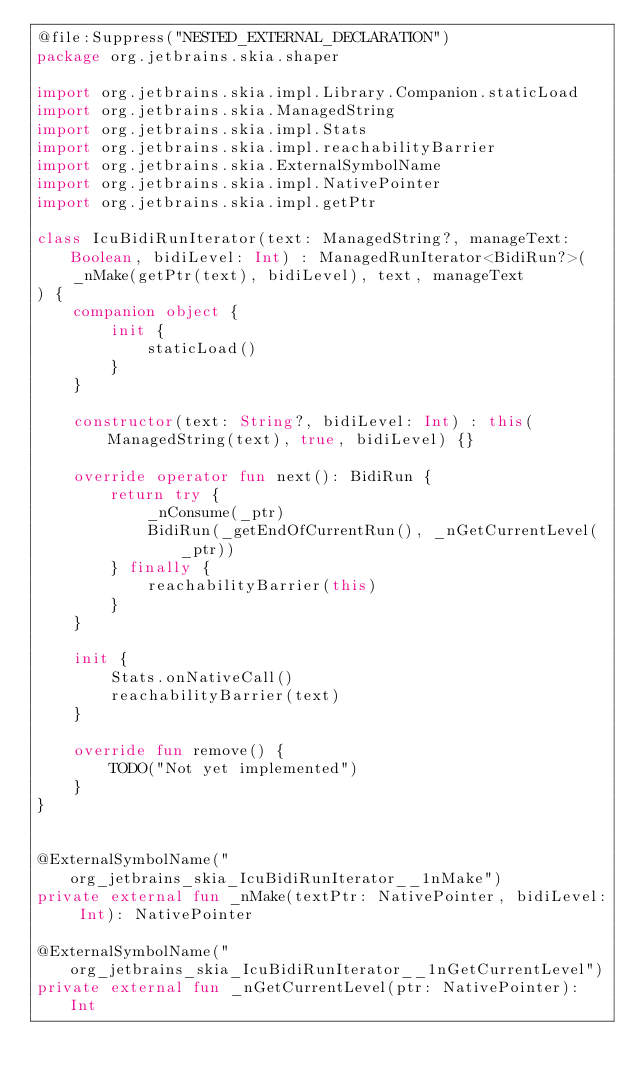Convert code to text. <code><loc_0><loc_0><loc_500><loc_500><_Kotlin_>@file:Suppress("NESTED_EXTERNAL_DECLARATION")
package org.jetbrains.skia.shaper

import org.jetbrains.skia.impl.Library.Companion.staticLoad
import org.jetbrains.skia.ManagedString
import org.jetbrains.skia.impl.Stats
import org.jetbrains.skia.impl.reachabilityBarrier
import org.jetbrains.skia.ExternalSymbolName
import org.jetbrains.skia.impl.NativePointer
import org.jetbrains.skia.impl.getPtr

class IcuBidiRunIterator(text: ManagedString?, manageText: Boolean, bidiLevel: Int) : ManagedRunIterator<BidiRun?>(
    _nMake(getPtr(text), bidiLevel), text, manageText
) {
    companion object {
        init {
            staticLoad()
        }
    }

    constructor(text: String?, bidiLevel: Int) : this(ManagedString(text), true, bidiLevel) {}

    override operator fun next(): BidiRun {
        return try {
            _nConsume(_ptr)
            BidiRun(_getEndOfCurrentRun(), _nGetCurrentLevel(_ptr))
        } finally {
            reachabilityBarrier(this)
        }
    }

    init {
        Stats.onNativeCall()
        reachabilityBarrier(text)
    }

    override fun remove() {
        TODO("Not yet implemented")
    }
}


@ExternalSymbolName("org_jetbrains_skia_IcuBidiRunIterator__1nMake")
private external fun _nMake(textPtr: NativePointer, bidiLevel: Int): NativePointer

@ExternalSymbolName("org_jetbrains_skia_IcuBidiRunIterator__1nGetCurrentLevel")
private external fun _nGetCurrentLevel(ptr: NativePointer): Int
</code> 